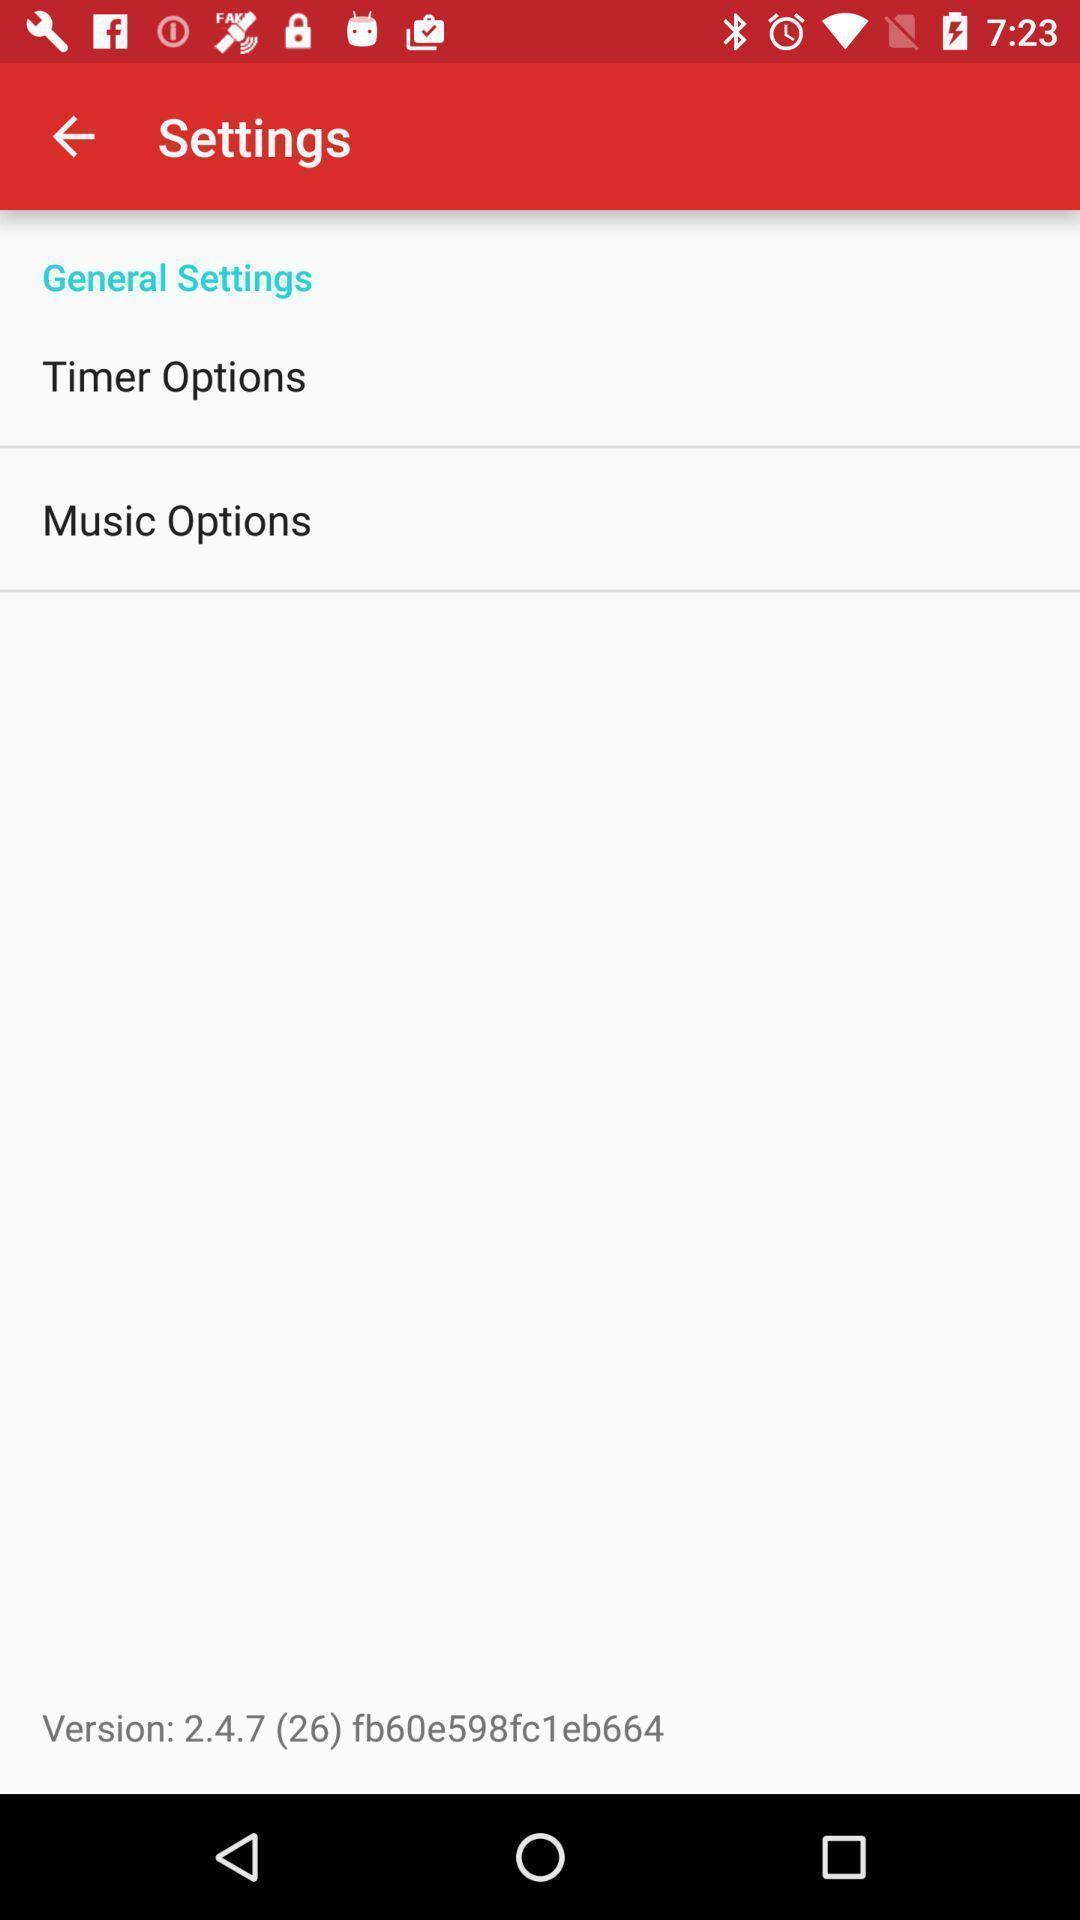Give me a summary of this screen capture. Settings page with two more options in banking app. 